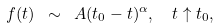Convert formula to latex. <formula><loc_0><loc_0><loc_500><loc_500>f ( t ) \ \sim \ A ( t _ { 0 } - t ) ^ { \alpha } , \ \ t \uparrow t _ { 0 } ,</formula> 